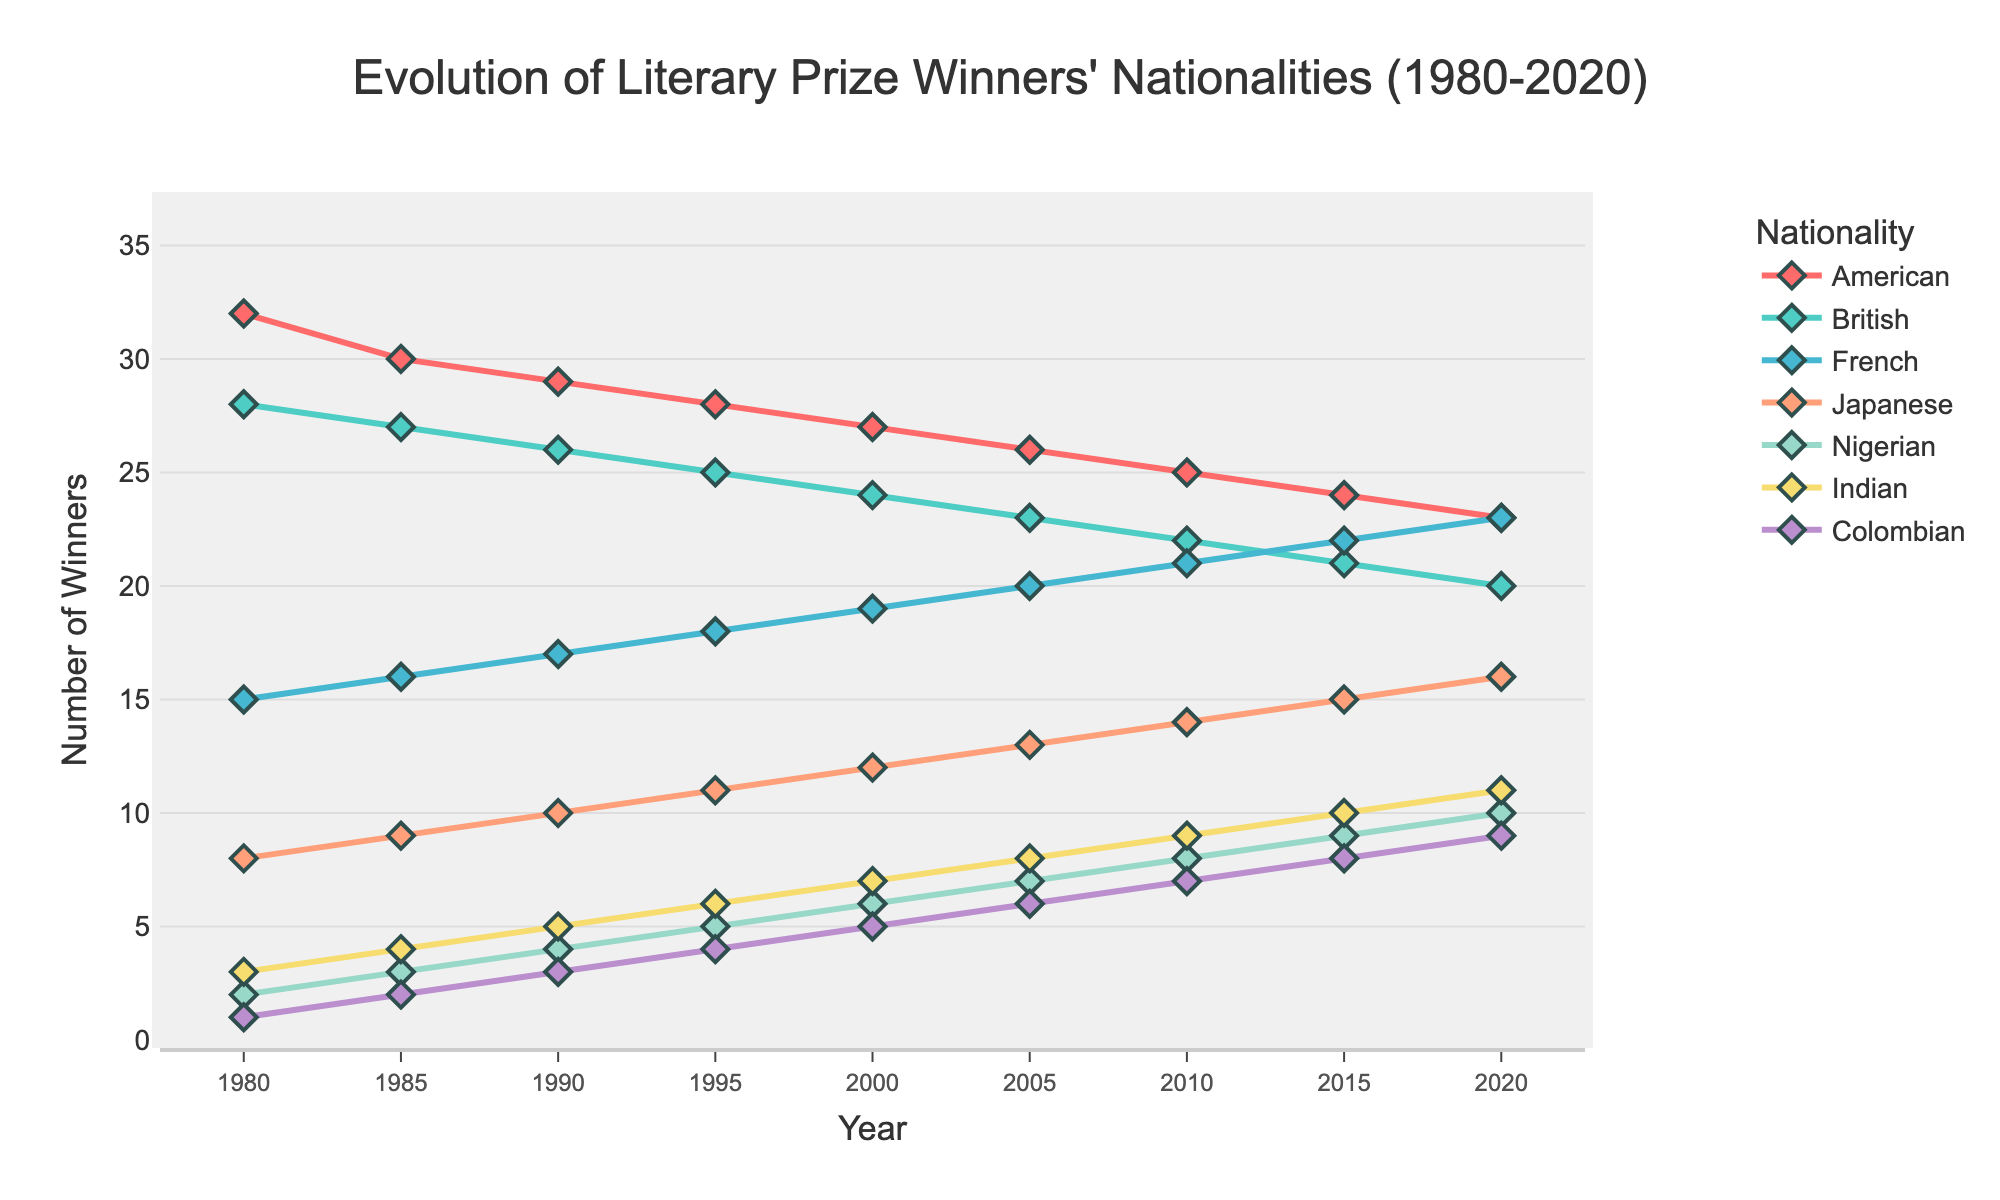What's the nationality with the most consistent number of winners from 1980 to 2020? To identify the most consistent nationality in terms of the number of winners, observe the lines' slopes in the chart; the American line shows the least fluctuation over the years.
Answer: American Which nationality saw the highest increase in the number of winners from 1980 to 2020? Calculate the difference between the values in 2020 and 1980 for each nationality. The Colombian nationality has the highest increase, from 1 winner in 1980 to 9 winners in 2020, an increase of 8 winners.
Answer: Colombian In which year did British and American winners have the same number? Track the points where the British and American lines intersect. In 1980, both British and American winners had 28 and 32 respectively, so there isn't an intersection point. Review visually to ensure no intersection. They remained different throughout the years.
Answer: Never How many additional winners did the French nationality need in 2020 to equal the number of winners from the American nationality? Subtract the number of French winners in 2020 (23) from the number of American winners in 2020 (23). Since they both have the same number of winners already, the result is zero.
Answer: 0 If we sum up the total number of winners for Nigerian and Indian nationalities in 2020, what would the result be? Add the numbers for Nigerian (10) and Indian (11) nationalities in 2020. 10 + 11 = 21.
Answer: 21 By how many winners did the Japanese nationality surpass the French nationality in 2010? Identify the number of winners for both Japanese (14) and French (21) in 2010. Subtract the two values: 21 - 14 = -7 (Japanese did not surpass; French had more).
Answer: Did not surpass What is the average number of winners for Nigerian nationality from 1980 to 2020? Sum the Nigerian winners for all years and divide by the number of years: (2 + 3 + 4 + 5 + 6 + 7 + 8 + 9 + 10) / 9 = 54 / 9 = 6.
Answer: 6 Among the given nationalities, which one started with the least number of winners in 1980 and ended up with more than 5 by 2020? Identify the 1980 and 2020 values for each nationality. Colombian started with the least in 1980 (1) and ended up with 9 in 2020.
Answer: Colombian 